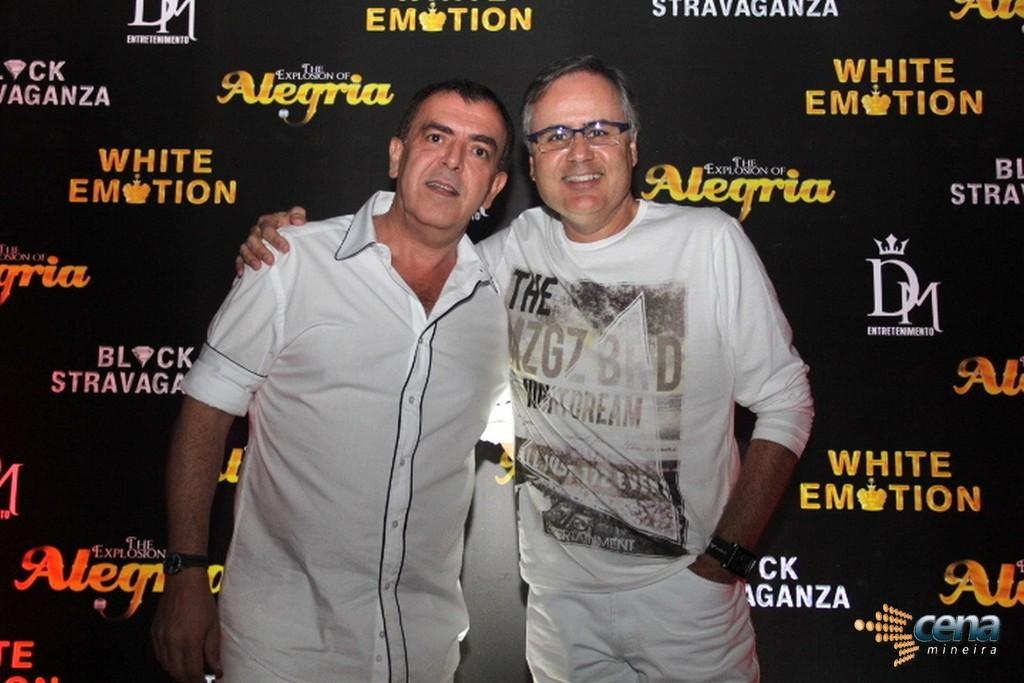<image>
Render a clear and concise summary of the photo. Two men stand in front of a poster board with DM printed on it.. 